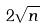Convert formula to latex. <formula><loc_0><loc_0><loc_500><loc_500>2 \sqrt { n }</formula> 